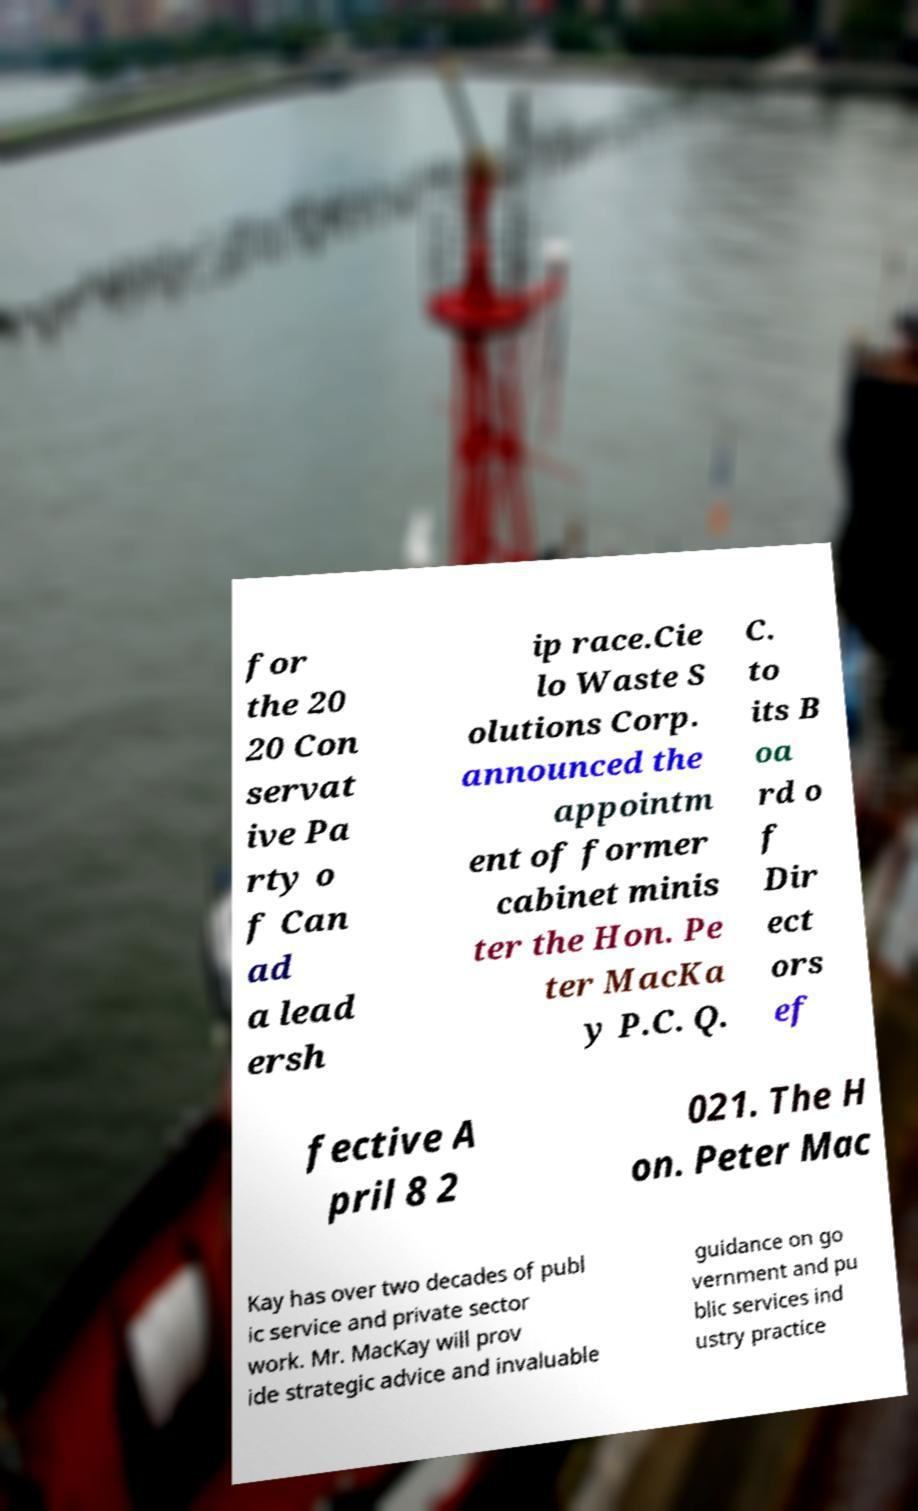There's text embedded in this image that I need extracted. Can you transcribe it verbatim? for the 20 20 Con servat ive Pa rty o f Can ad a lead ersh ip race.Cie lo Waste S olutions Corp. announced the appointm ent of former cabinet minis ter the Hon. Pe ter MacKa y P.C. Q. C. to its B oa rd o f Dir ect ors ef fective A pril 8 2 021. The H on. Peter Mac Kay has over two decades of publ ic service and private sector work. Mr. MacKay will prov ide strategic advice and invaluable guidance on go vernment and pu blic services ind ustry practice 